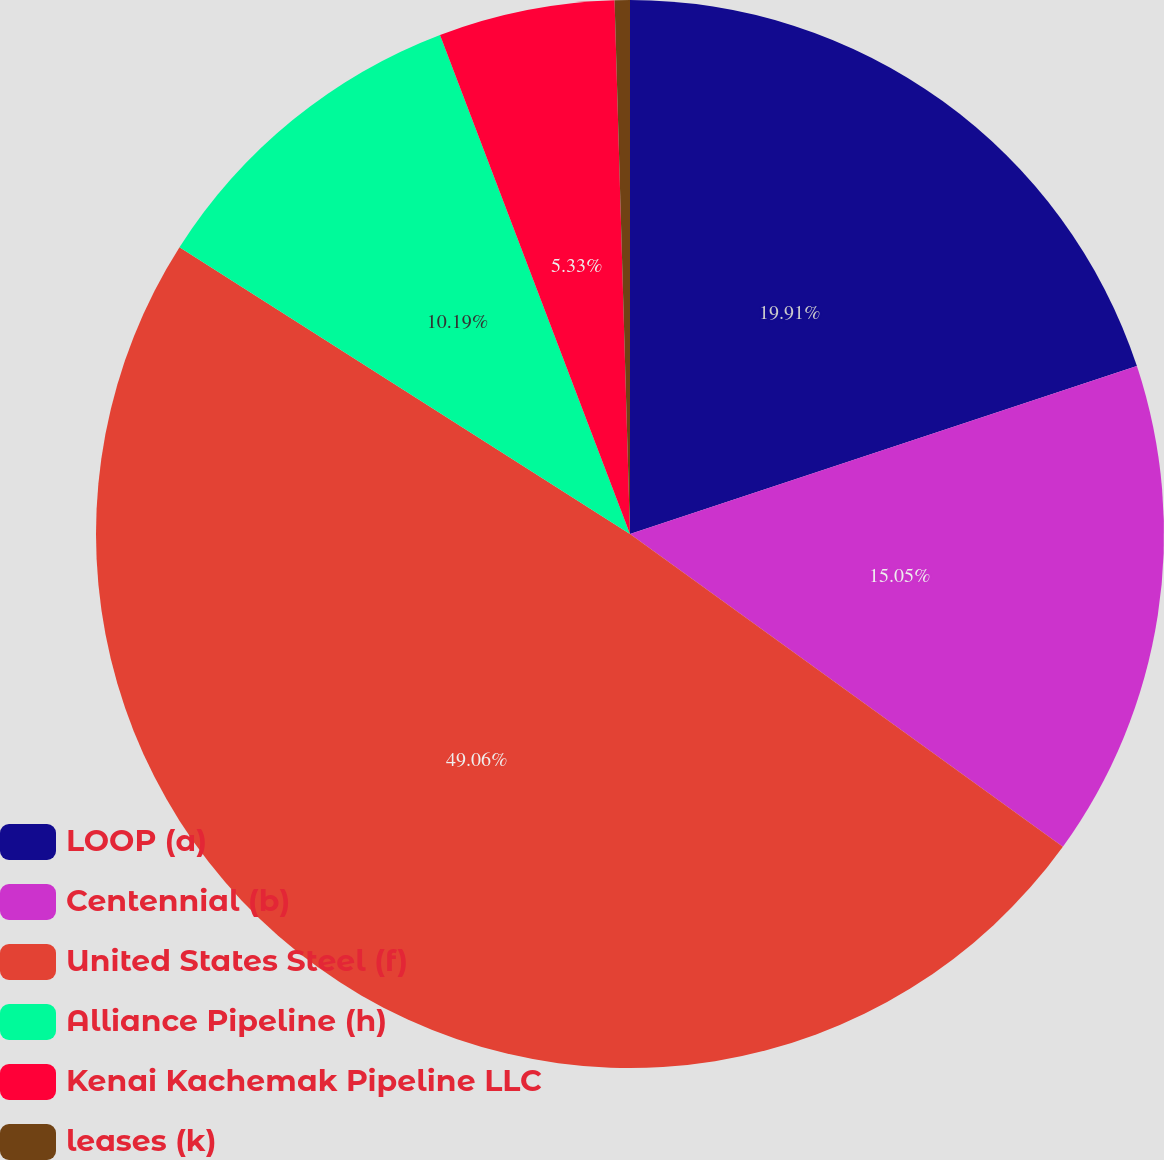Convert chart to OTSL. <chart><loc_0><loc_0><loc_500><loc_500><pie_chart><fcel>LOOP (a)<fcel>Centennial (b)<fcel>United States Steel (f)<fcel>Alliance Pipeline (h)<fcel>Kenai Kachemak Pipeline LLC<fcel>leases (k)<nl><fcel>19.91%<fcel>15.05%<fcel>49.07%<fcel>10.19%<fcel>5.33%<fcel>0.46%<nl></chart> 